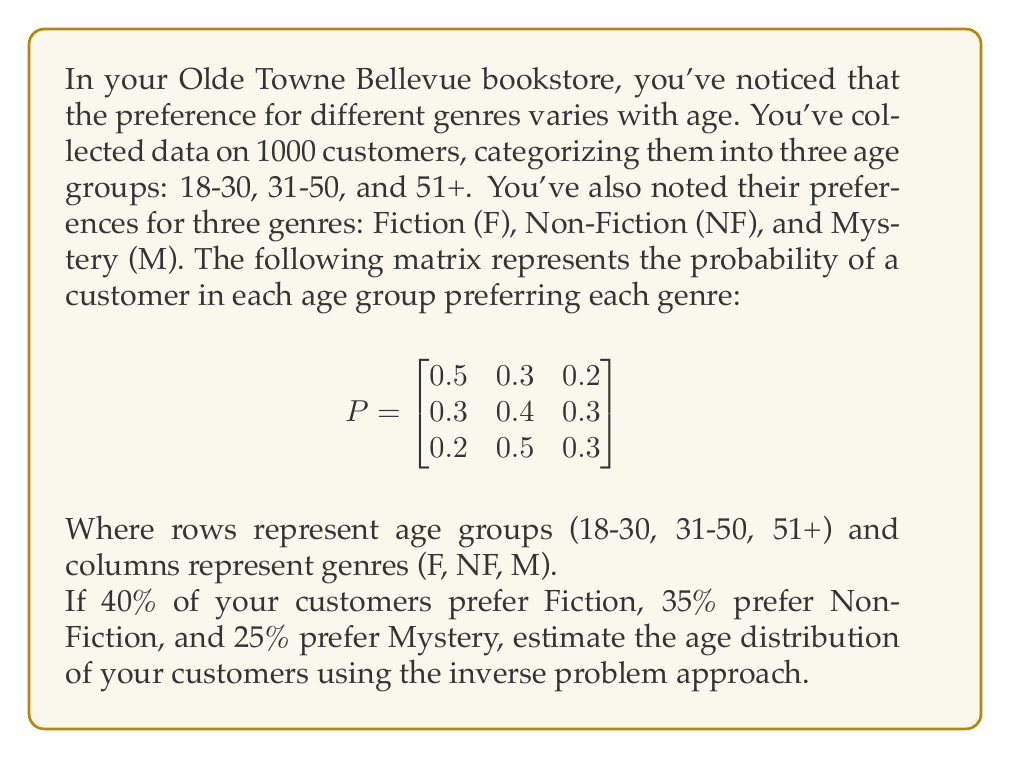Could you help me with this problem? To solve this inverse problem, we'll use the following steps:

1) Let $x = [x_1, x_2, x_3]^T$ be the unknown age distribution we're trying to estimate, where $x_1$, $x_2$, and $x_3$ represent the proportions of customers in the 18-30, 31-50, and 51+ age groups respectively.

2) We know the genre preference distribution $b = [0.4, 0.35, 0.25]^T$ for Fiction, Non-Fiction, and Mystery.

3) The forward problem is represented by the equation $Px = b$, where $P$ is the given probability matrix.

4) To solve the inverse problem, we need to find $x$ given $P$ and $b$. Mathematically, this is $x = P^{-1}b$.

5) First, let's calculate $P^{-1}$:

   $$P^{-1} = \begin{bmatrix}
   3.75 & -1.875 & -0.625 \\
   -1.5 & 1.75 & 0.25 \\
   -1.5 & 0.375 & 1.625
   \end{bmatrix}$$

6) Now, we can calculate $x$:

   $$x = P^{-1}b = \begin{bmatrix}
   3.75 & -1.875 & -0.625 \\
   -1.5 & 1.75 & 0.25 \\
   -1.5 & 0.375 & 1.625
   \end{bmatrix} \begin{bmatrix}
   0.4 \\
   0.35 \\
   0.25
   \end{bmatrix}$$

7) Performing the matrix multiplication:

   $$x = \begin{bmatrix}
   3.75(0.4) + (-1.875)(0.35) + (-0.625)(0.25) \\
   (-1.5)(0.4) + 1.75(0.35) + 0.25(0.25) \\
   (-1.5)(0.4) + 0.375(0.35) + 1.625(0.25)
   \end{bmatrix} = \begin{bmatrix}
   0.725 \\
   0.225 \\
   0.05
   \end{bmatrix}$$

8) Therefore, the estimated age distribution is:
   18-30: 72.5%
   31-50: 22.5%
   51+: 5%

Note: The small discrepancies in the sum (100.5%) are due to rounding in the calculations.
Answer: [0.725, 0.225, 0.05] 